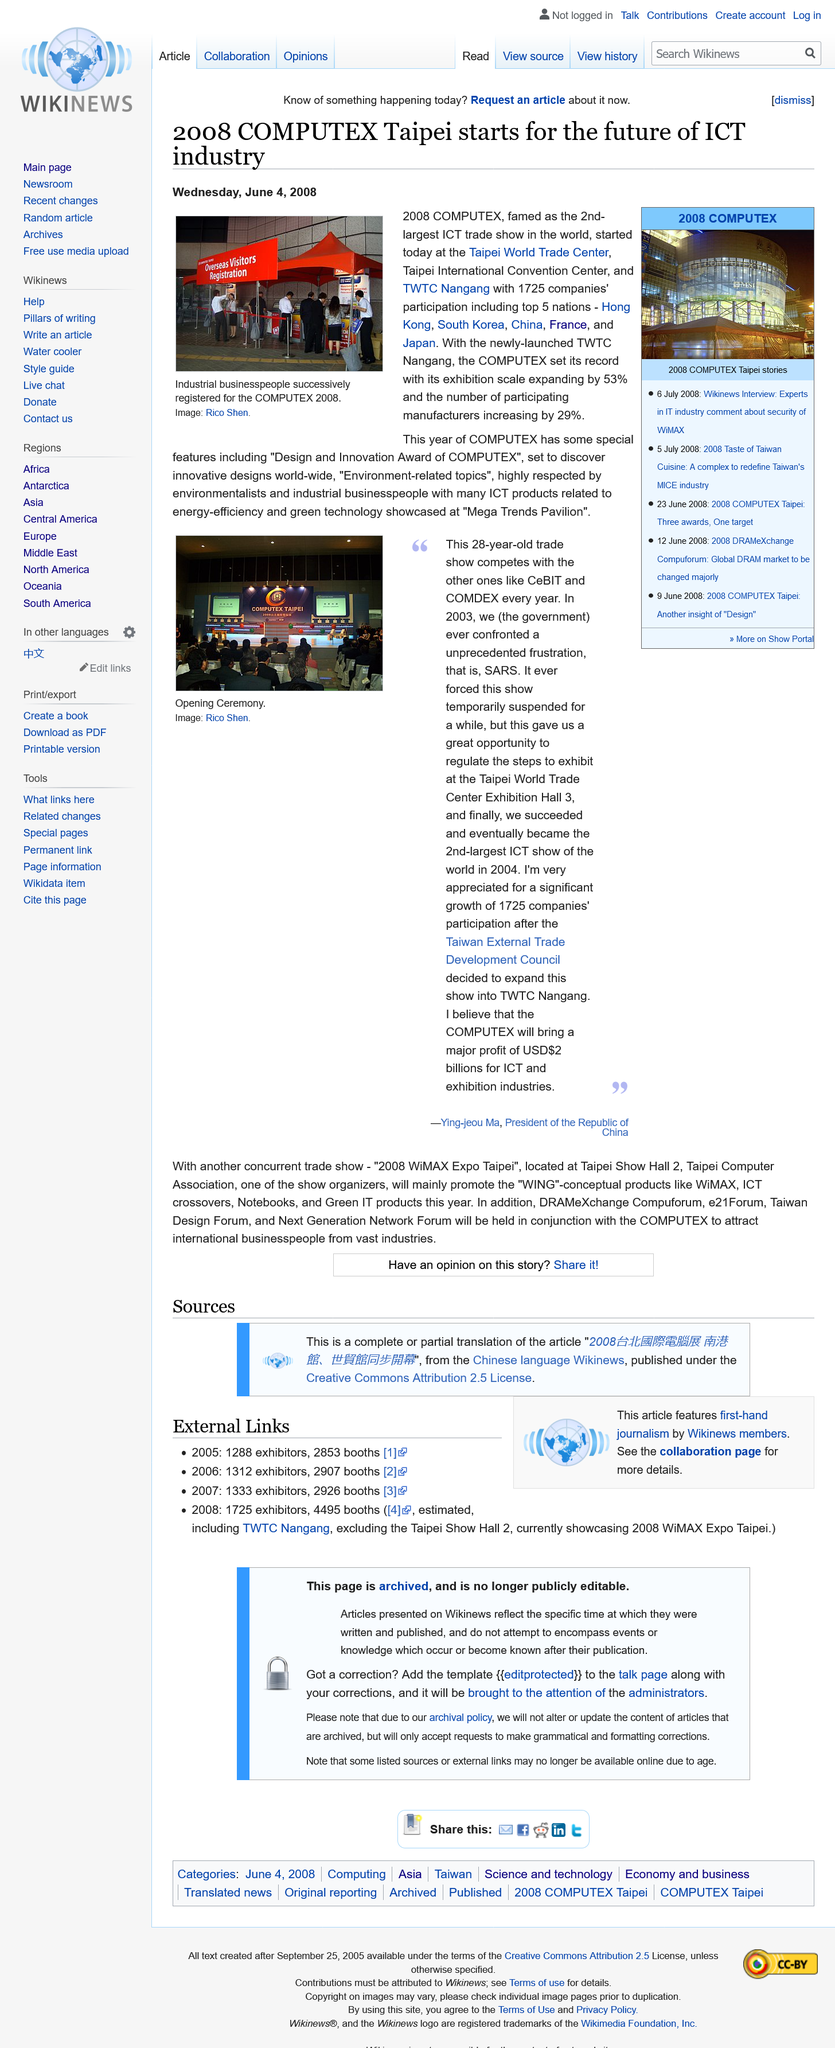Give some essential details in this illustration. Ying-jeou Ma is the President of the Republic of China. The image was taken by Rico Shen. In 2004, Ying-jeou Ma, the President of the Republic of China, declared that his country had successfully become the second largest ICT show in the world. This article was published in June, and the month in which it was published is June. The ICT trade show mentioned in this article is called 2008 COMPUTEX. 